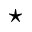Convert formula to latex. <formula><loc_0><loc_0><loc_500><loc_500>^ { * }</formula> 